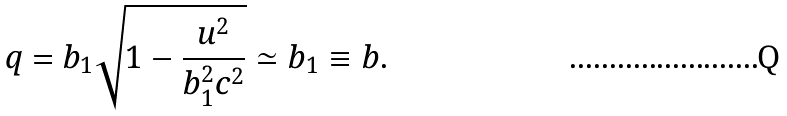Convert formula to latex. <formula><loc_0><loc_0><loc_500><loc_500>q = b _ { 1 } \sqrt { 1 - \frac { u ^ { 2 } } { b _ { 1 } ^ { 2 } c ^ { 2 } } } \simeq b _ { 1 } \equiv b .</formula> 